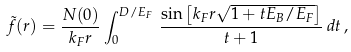<formula> <loc_0><loc_0><loc_500><loc_500>\tilde { f } ( r ) = \frac { N ( 0 ) } { k _ { F } r } \int _ { 0 } ^ { D / E _ { F } } \, \frac { \sin \left [ k _ { F } r \sqrt { 1 + t E _ { B } / E _ { F } } \right ] } { t + 1 } \, d t \, ,</formula> 